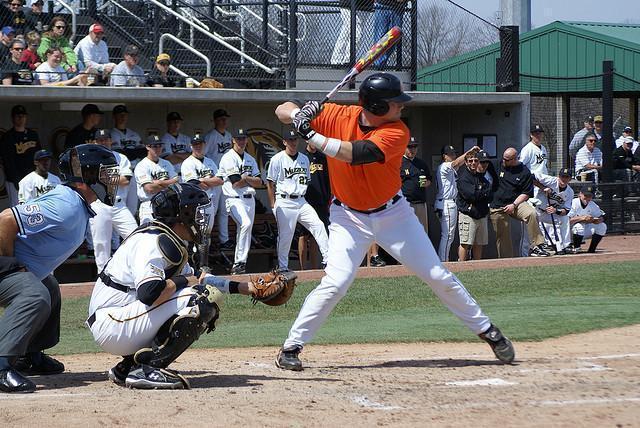What is the brown object in the squatting man's hand?
Choose the correct response and explain in the format: 'Answer: answer
Rationale: rationale.'
Options: Football, resin, glove, pretzel. Answer: glove.
Rationale: The other options don't match this sport. 